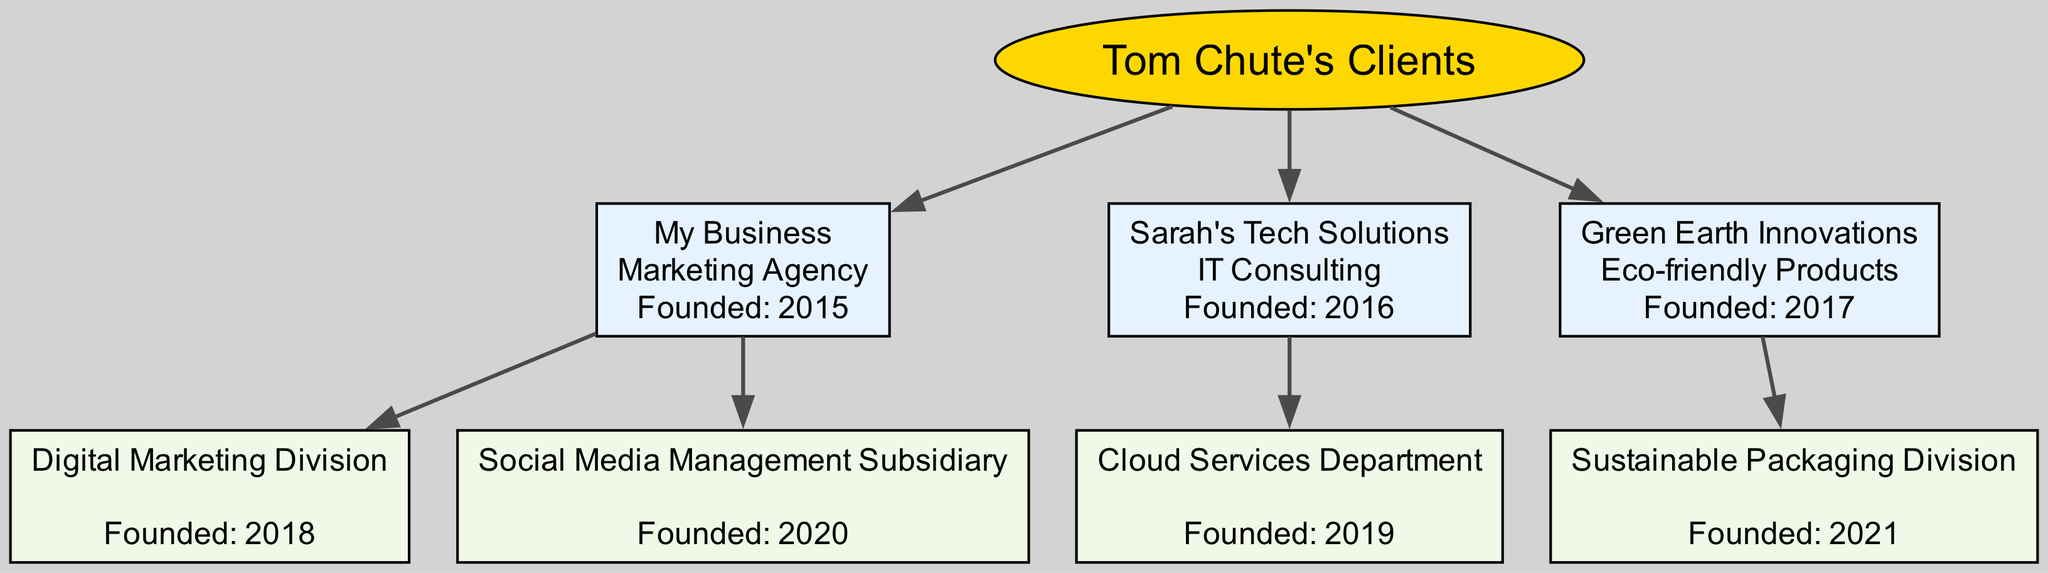What is the type of "My Business"? Looking at the node representing "My Business," it can be seen that there is a line labeled "type: Marketing Agency" beneath the name of the business. This is a direct descriptor of the business.
Answer: Marketing Agency How many businesses were founded in 2016? By reviewing the diagram and counting the businesses that were founded in the year 2016, we find that both "Sarah's Tech Solutions" and "My Business" fall into this category. Thus, the total count is determined.
Answer: 1 Which business has a "Cloud Services Department"? The node labeled "Cloud Services Department" indicates it is a subsidiary of "Sarah's Tech Solutions." By tracing the connection upwards, it's clear this department is part of "Sarah's Tech Solutions."
Answer: Sarah's Tech Solutions What year was the Sustainable Packaging Division founded? The node for "Sustainable Packaging Division" specifies that it was founded in 2021, which is stated directly on the node itself.
Answer: 2021 How many total divisions/subsidiaries does "My Business" have? By examining the children of "My Business," we can see that there are two divisions: "Digital Marketing Division" and "Social Media Management Subsidiary." Counting these gives the total number of divisions.
Answer: 2 Which business type does "Green Earth Innovations" represent? Referring to the information in the node for "Green Earth Innovations," it states "type: Eco-friendly Products," signifying the nature of the business.
Answer: Eco-friendly Products What is the foundation year of "Sarah's Tech Solutions"? On the node for "Sarah's Tech Solutions," there is a mention of "Founded: 2016," providing a specific year when the business was established.
Answer: 2016 Who is the parent company of the Digital Marketing Division? The hierarchy in the diagram shows that the "Digital Marketing Division" is under "My Business," making it the parent company. This can be visually traced through their connection in the diagram.
Answer: My Business 